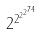<formula> <loc_0><loc_0><loc_500><loc_500>2 ^ { 2 ^ { 2 ^ { 2 ^ { 7 4 } } } }</formula> 